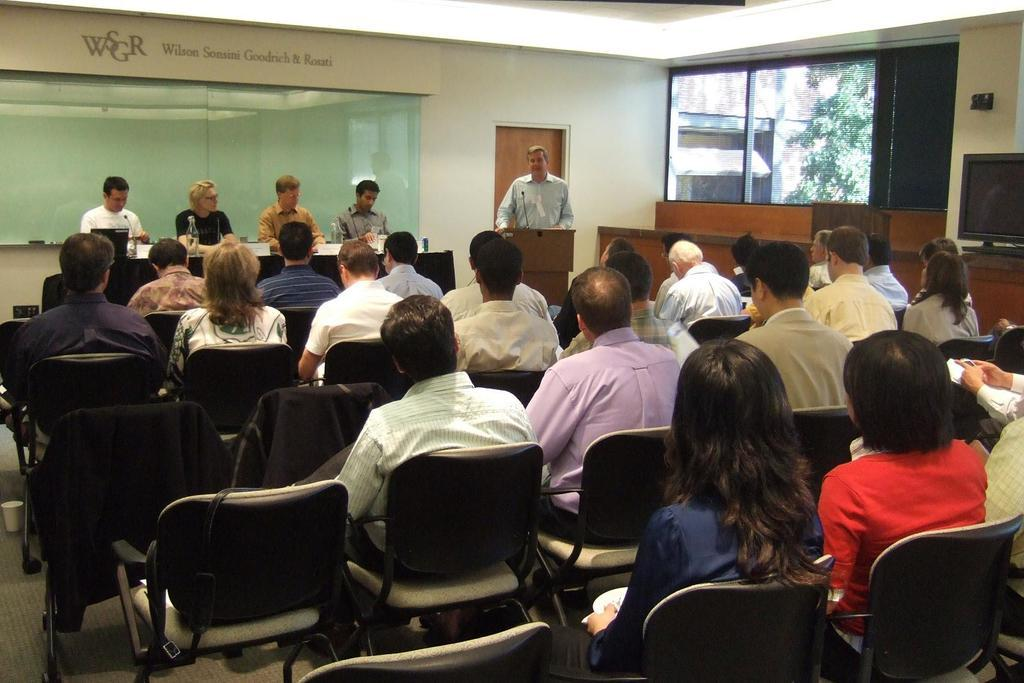How many people are in the image? There are multiple people in the image. What are the people doing in the image? The people are sitting on chairs. Is there anyone standing in the image? Yes, there is a man standing in the image. How many ladybugs can be seen on the man's shirt in the image? There are no ladybugs present in the image. What type of pie is being served to the people in the image? There is no pie present in the image. 